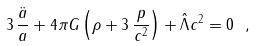<formula> <loc_0><loc_0><loc_500><loc_500>3 \, \frac { \ddot { a } } { a } + 4 \pi G \left ( \rho + 3 \, \frac { p } { c ^ { 2 } } \right ) + \hat { \Lambda } c ^ { 2 } = 0 \ ,</formula> 